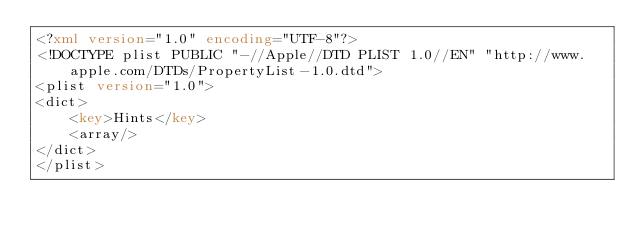<code> <loc_0><loc_0><loc_500><loc_500><_XML_><?xml version="1.0" encoding="UTF-8"?>
<!DOCTYPE plist PUBLIC "-//Apple//DTD PLIST 1.0//EN" "http://www.apple.com/DTDs/PropertyList-1.0.dtd">
<plist version="1.0">
<dict>
	<key>Hints</key>
	<array/>
</dict>
</plist>
</code> 